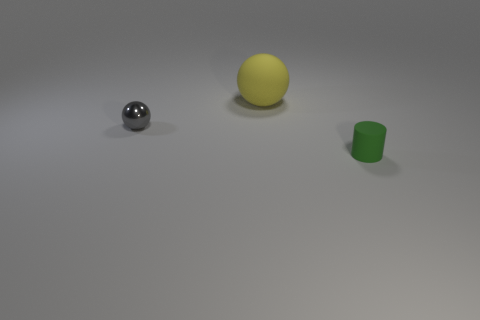Do the green matte thing and the metal ball have the same size?
Keep it short and to the point. Yes. There is a green matte cylinder; is it the same size as the sphere that is behind the tiny metal ball?
Keep it short and to the point. No. There is a object that is both in front of the big yellow thing and on the left side of the matte cylinder; what is its color?
Your response must be concise. Gray. Is the number of balls that are right of the small rubber object greater than the number of tiny cylinders that are behind the large yellow rubber thing?
Give a very brief answer. No. The ball that is the same material as the green thing is what size?
Ensure brevity in your answer.  Large. There is a small object in front of the gray ball; what number of spheres are right of it?
Give a very brief answer. 0. Are there any small cyan matte things of the same shape as the yellow matte object?
Ensure brevity in your answer.  No. What color is the small object behind the tiny thing on the right side of the small metallic object?
Offer a very short reply. Gray. Is the number of big red cylinders greater than the number of yellow balls?
Make the answer very short. No. What number of gray shiny objects are the same size as the green thing?
Give a very brief answer. 1. 